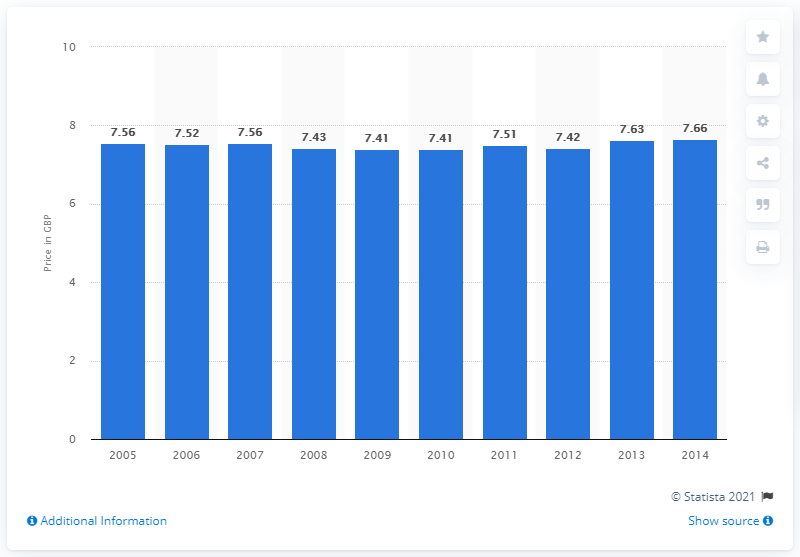Mention a couple of crucial points in this snapshot. In 2005, the average book price in the UK began to increase. 